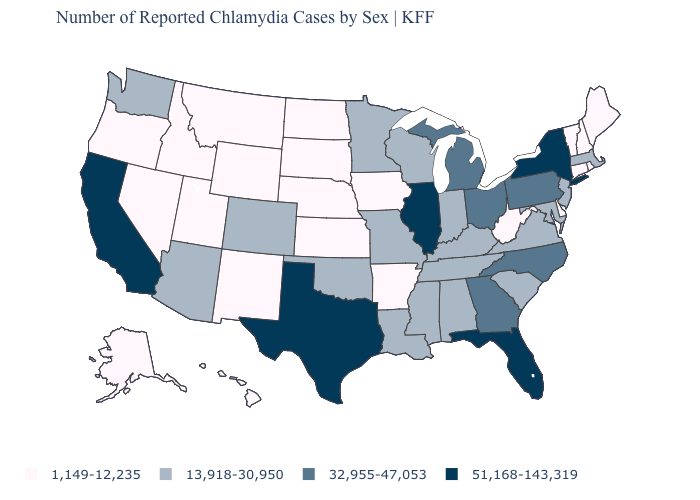Name the states that have a value in the range 32,955-47,053?
Answer briefly. Georgia, Michigan, North Carolina, Ohio, Pennsylvania. Does the map have missing data?
Give a very brief answer. No. What is the value of Ohio?
Be succinct. 32,955-47,053. Is the legend a continuous bar?
Be succinct. No. What is the lowest value in the USA?
Quick response, please. 1,149-12,235. Name the states that have a value in the range 1,149-12,235?
Keep it brief. Alaska, Arkansas, Connecticut, Delaware, Hawaii, Idaho, Iowa, Kansas, Maine, Montana, Nebraska, Nevada, New Hampshire, New Mexico, North Dakota, Oregon, Rhode Island, South Dakota, Utah, Vermont, West Virginia, Wyoming. Among the states that border New York , does Connecticut have the lowest value?
Keep it brief. Yes. Name the states that have a value in the range 51,168-143,319?
Keep it brief. California, Florida, Illinois, New York, Texas. Does Indiana have the lowest value in the USA?
Short answer required. No. What is the value of North Carolina?
Answer briefly. 32,955-47,053. Among the states that border Massachusetts , which have the lowest value?
Concise answer only. Connecticut, New Hampshire, Rhode Island, Vermont. What is the highest value in the West ?
Short answer required. 51,168-143,319. How many symbols are there in the legend?
Keep it brief. 4. Name the states that have a value in the range 13,918-30,950?
Quick response, please. Alabama, Arizona, Colorado, Indiana, Kentucky, Louisiana, Maryland, Massachusetts, Minnesota, Mississippi, Missouri, New Jersey, Oklahoma, South Carolina, Tennessee, Virginia, Washington, Wisconsin. Does Arkansas have the same value as Maine?
Be succinct. Yes. 